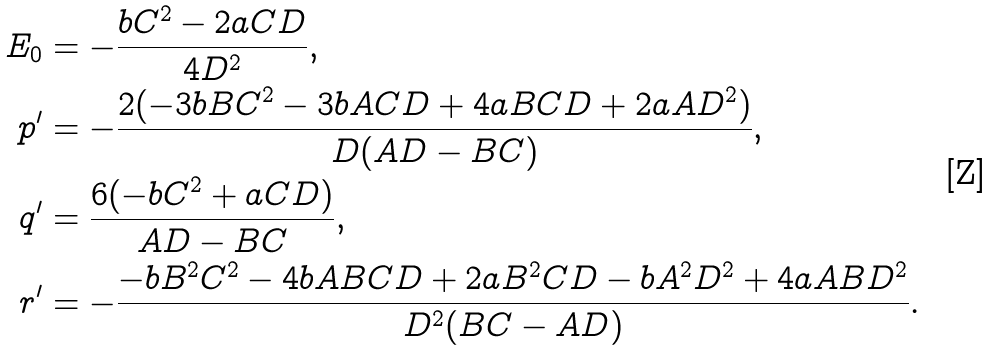Convert formula to latex. <formula><loc_0><loc_0><loc_500><loc_500>E _ { 0 } & = - \frac { b C ^ { 2 } - 2 a C D } { 4 D ^ { 2 } } , \\ p ^ { \prime } & = - \frac { 2 ( - 3 b B C ^ { 2 } - 3 b A C D + 4 a B C D + 2 a A D ^ { 2 } ) } { D ( A D - B C ) } , \\ q ^ { \prime } & = \frac { 6 ( - b C ^ { 2 } + a C D ) } { A D - B C } , \\ r ^ { \prime } & = - \frac { - b B ^ { 2 } C ^ { 2 } - 4 b A B C D + 2 a B ^ { 2 } C D - b A ^ { 2 } D ^ { 2 } + 4 a A B D ^ { 2 } } { D ^ { 2 } ( B C - A D ) } .</formula> 